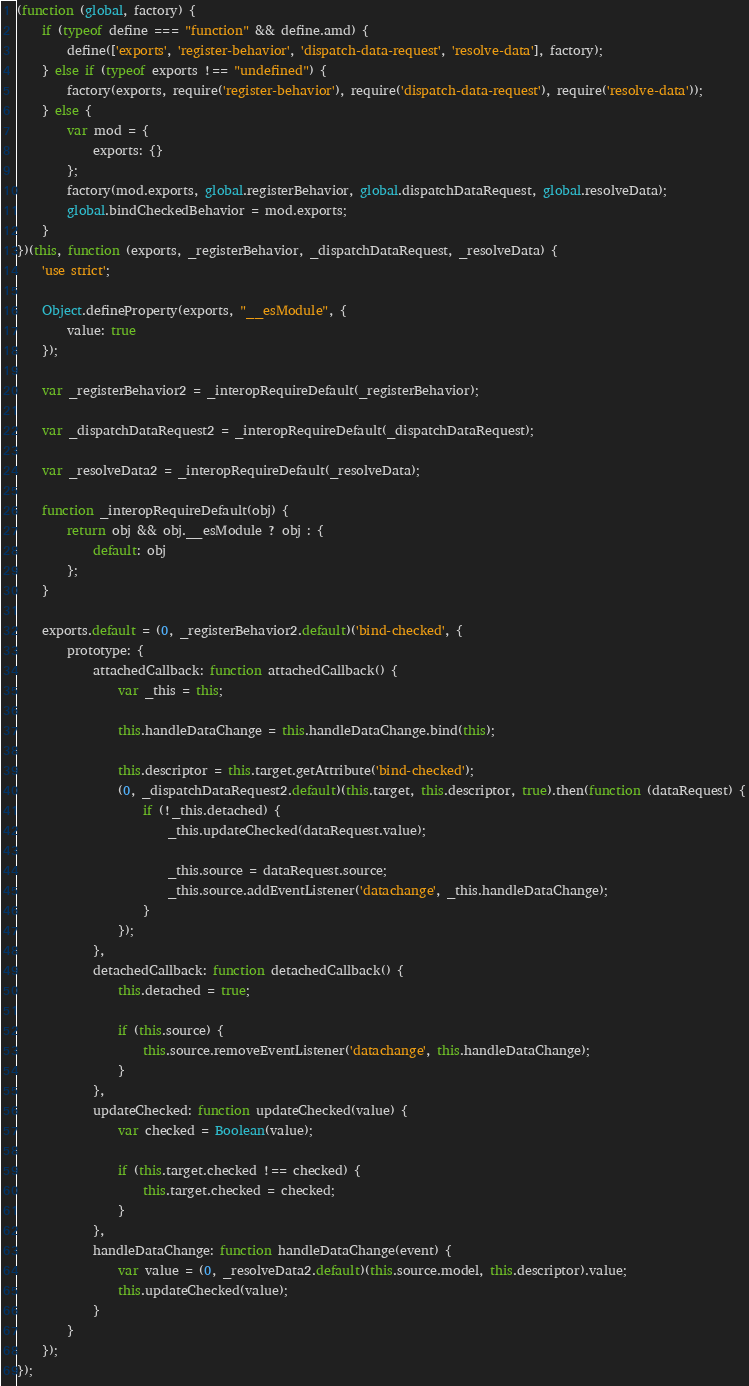<code> <loc_0><loc_0><loc_500><loc_500><_JavaScript_>(function (global, factory) {
	if (typeof define === "function" && define.amd) {
		define(['exports', 'register-behavior', 'dispatch-data-request', 'resolve-data'], factory);
	} else if (typeof exports !== "undefined") {
		factory(exports, require('register-behavior'), require('dispatch-data-request'), require('resolve-data'));
	} else {
		var mod = {
			exports: {}
		};
		factory(mod.exports, global.registerBehavior, global.dispatchDataRequest, global.resolveData);
		global.bindCheckedBehavior = mod.exports;
	}
})(this, function (exports, _registerBehavior, _dispatchDataRequest, _resolveData) {
	'use strict';

	Object.defineProperty(exports, "__esModule", {
		value: true
	});

	var _registerBehavior2 = _interopRequireDefault(_registerBehavior);

	var _dispatchDataRequest2 = _interopRequireDefault(_dispatchDataRequest);

	var _resolveData2 = _interopRequireDefault(_resolveData);

	function _interopRequireDefault(obj) {
		return obj && obj.__esModule ? obj : {
			default: obj
		};
	}

	exports.default = (0, _registerBehavior2.default)('bind-checked', {
		prototype: {
			attachedCallback: function attachedCallback() {
				var _this = this;

				this.handleDataChange = this.handleDataChange.bind(this);

				this.descriptor = this.target.getAttribute('bind-checked');
				(0, _dispatchDataRequest2.default)(this.target, this.descriptor, true).then(function (dataRequest) {
					if (!_this.detached) {
						_this.updateChecked(dataRequest.value);

						_this.source = dataRequest.source;
						_this.source.addEventListener('datachange', _this.handleDataChange);
					}
				});
			},
			detachedCallback: function detachedCallback() {
				this.detached = true;

				if (this.source) {
					this.source.removeEventListener('datachange', this.handleDataChange);
				}
			},
			updateChecked: function updateChecked(value) {
				var checked = Boolean(value);

				if (this.target.checked !== checked) {
					this.target.checked = checked;
				}
			},
			handleDataChange: function handleDataChange(event) {
				var value = (0, _resolveData2.default)(this.source.model, this.descriptor).value;
				this.updateChecked(value);
			}
		}
	});
});
</code> 